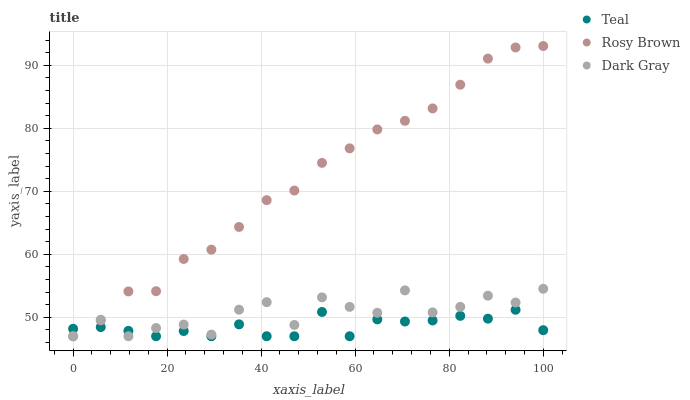Does Teal have the minimum area under the curve?
Answer yes or no. Yes. Does Rosy Brown have the maximum area under the curve?
Answer yes or no. Yes. Does Rosy Brown have the minimum area under the curve?
Answer yes or no. No. Does Teal have the maximum area under the curve?
Answer yes or no. No. Is Rosy Brown the smoothest?
Answer yes or no. Yes. Is Dark Gray the roughest?
Answer yes or no. Yes. Is Teal the smoothest?
Answer yes or no. No. Is Teal the roughest?
Answer yes or no. No. Does Dark Gray have the lowest value?
Answer yes or no. Yes. Does Rosy Brown have the highest value?
Answer yes or no. Yes. Does Teal have the highest value?
Answer yes or no. No. Does Rosy Brown intersect Teal?
Answer yes or no. Yes. Is Rosy Brown less than Teal?
Answer yes or no. No. Is Rosy Brown greater than Teal?
Answer yes or no. No. 